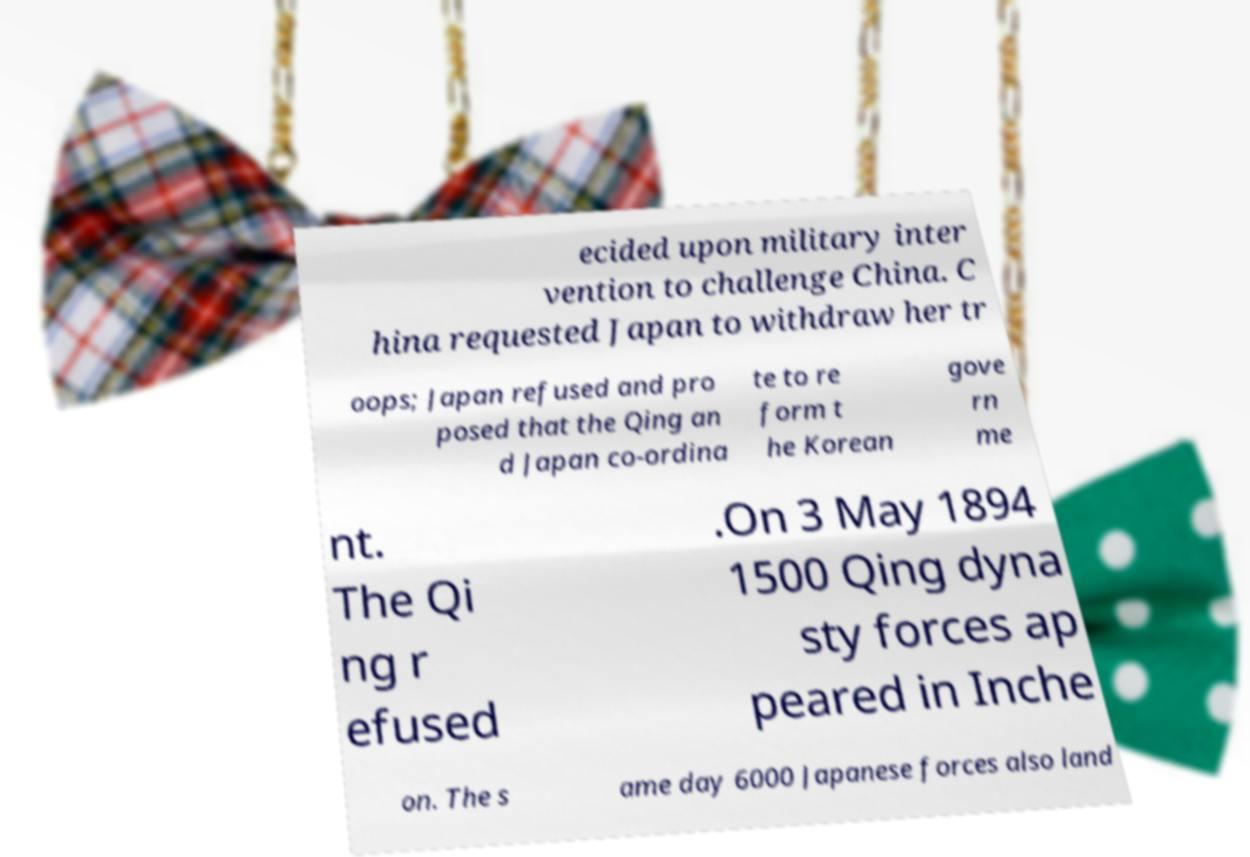Can you read and provide the text displayed in the image?This photo seems to have some interesting text. Can you extract and type it out for me? ecided upon military inter vention to challenge China. C hina requested Japan to withdraw her tr oops; Japan refused and pro posed that the Qing an d Japan co-ordina te to re form t he Korean gove rn me nt. The Qi ng r efused .On 3 May 1894 1500 Qing dyna sty forces ap peared in Inche on. The s ame day 6000 Japanese forces also land 